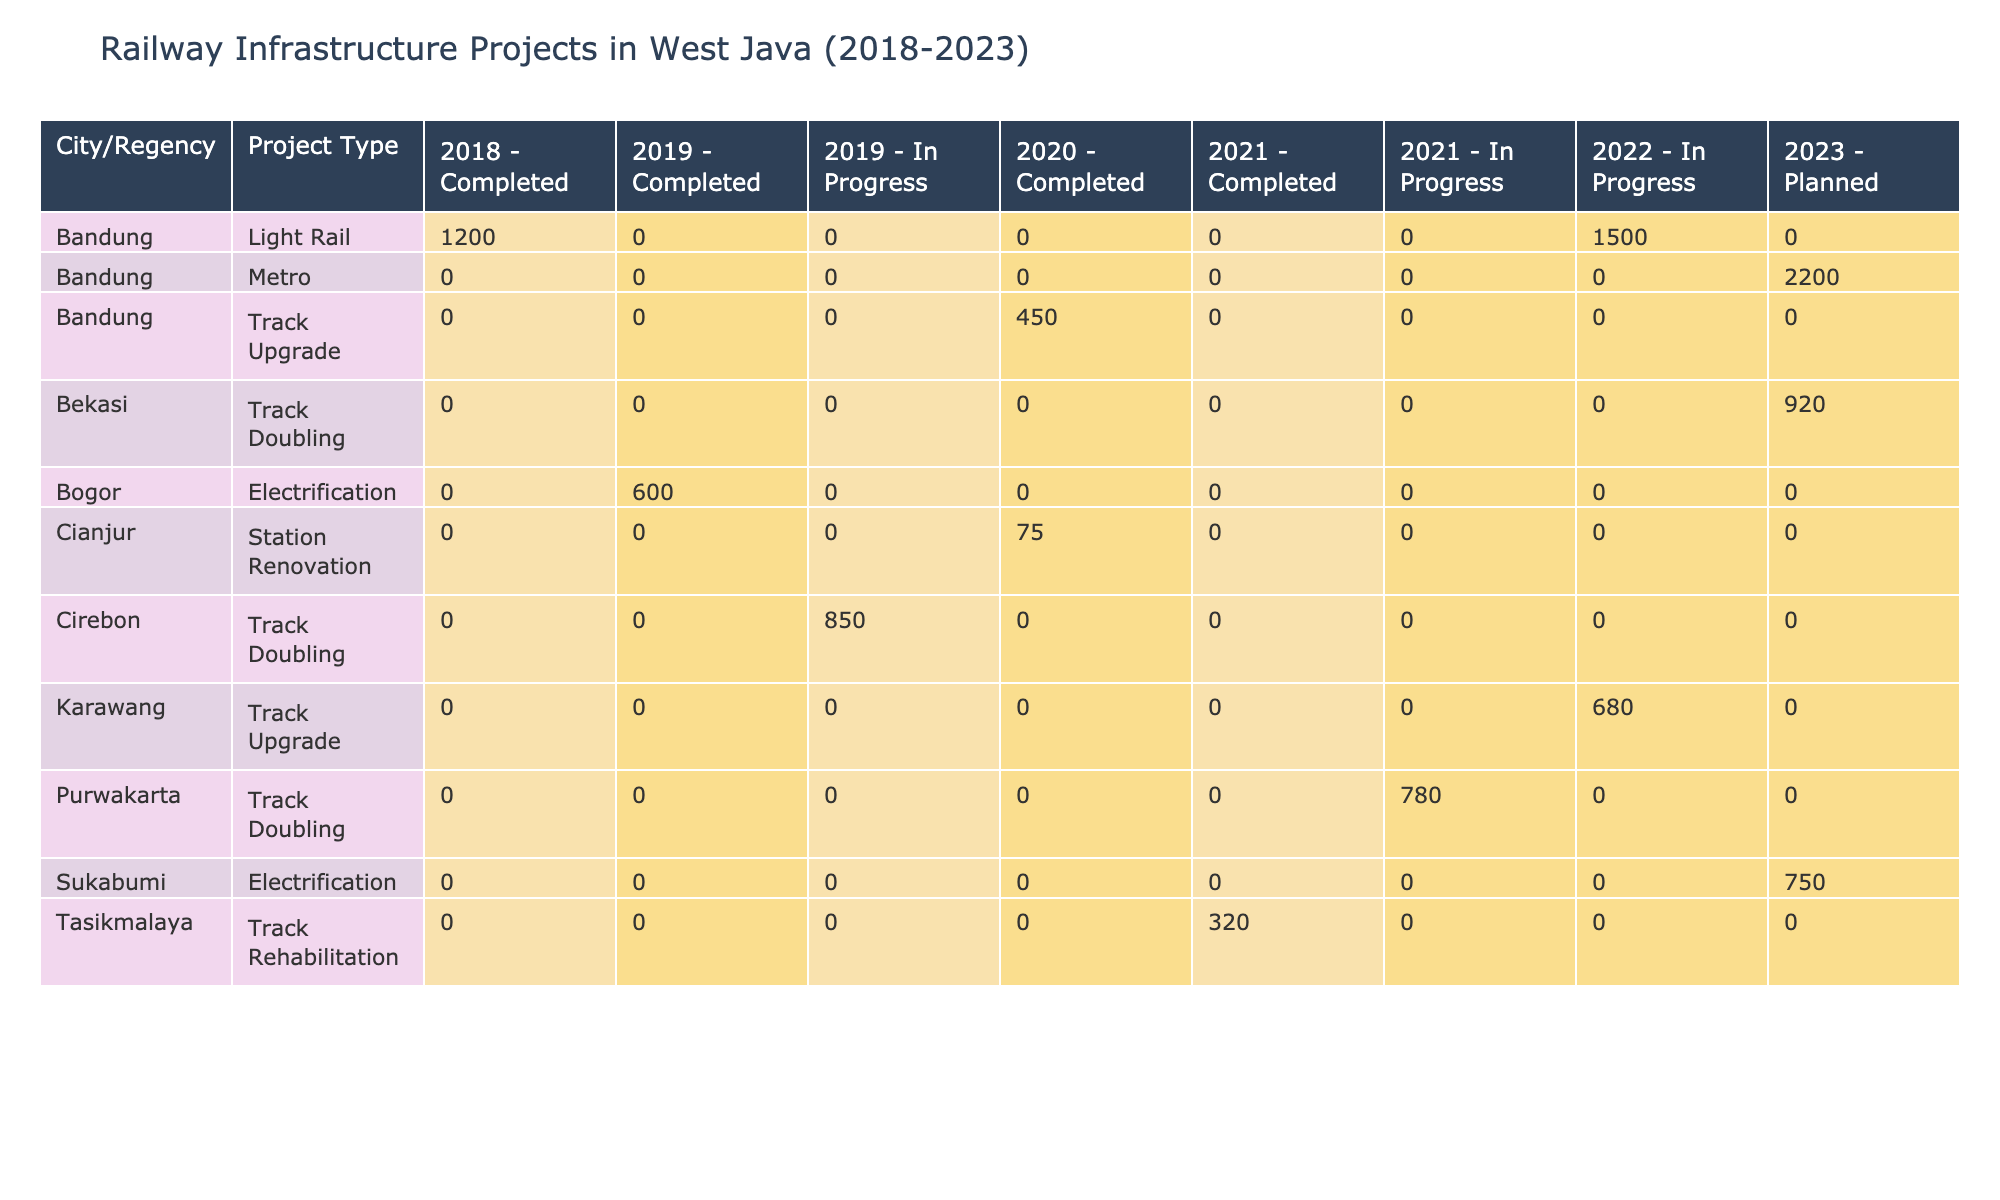What is the total budget for railway projects in Bandung from 2018 to 2023? The projects in Bandung include: 1200 billion IDR for the Bandung LRT Phase 1 (2018), 450 billion IDR for the Bandung-Padalarang Track Upgrade (2020), 1500 billion IDR for the Bandung LRT Phase 2 (2022), and 2200 billion IDR for the Bandung Metro Phase 1 (2023). Adding these amounts gives us 1200 + 450 + 1500 + 2200 = 4350 billion IDR.
Answer: 4350 billion IDR How many projects in Cirebon are marked as Completed? The table shows one project in Cirebon: the Cirebon-Semarang Double Track, which is listed as In Progress. Therefore, there are no completed projects in Cirebon.
Answer: 0 What type of project has the highest budget in 2023? In 2023, the projects are: 750 billion IDR for Sukabumi-Cianjur Track Electrification, 2200 billion IDR for Bandung Metro Phase 1, and 920 billion IDR for Bekasi-Karawang Double Track. The highest budget is for the Bandung Metro Phase 1 at 2200 billion IDR.
Answer: 2200 billion IDR Are there any Electrification projects in the completed status? The table lists Bogor-Sukabumi Electrification, which is marked as Completed. Therefore, the answer to this question is yes.
Answer: Yes What is the average budget of all the Track Doubling projects listed? The Track Doubling projects are: Cirebon-Semarang Double Track (850 billion IDR - In Progress), Purwakarta-Cikampek Double Track (780 billion IDR - In Progress), and Bekasi-Karawang Double Track (920 billion IDR - Planned). To find the average, first calculate the total budget: 850 + 780 + 920 = 2550 billion IDR. There are three projects, so the average is 2550 / 3 = 850 billion IDR.
Answer: 850 billion IDR How many projects are planned to be completed in 2023? The table shows two projects planned for 2023: Sukabumi-Cianjur Track Electrification and Bandung Metro Phase 1, which are not yet completed, and also Bekasi-Karawang Double Track, which is marked as Planned. Hence, the count is two planned projects.
Answer: 3 